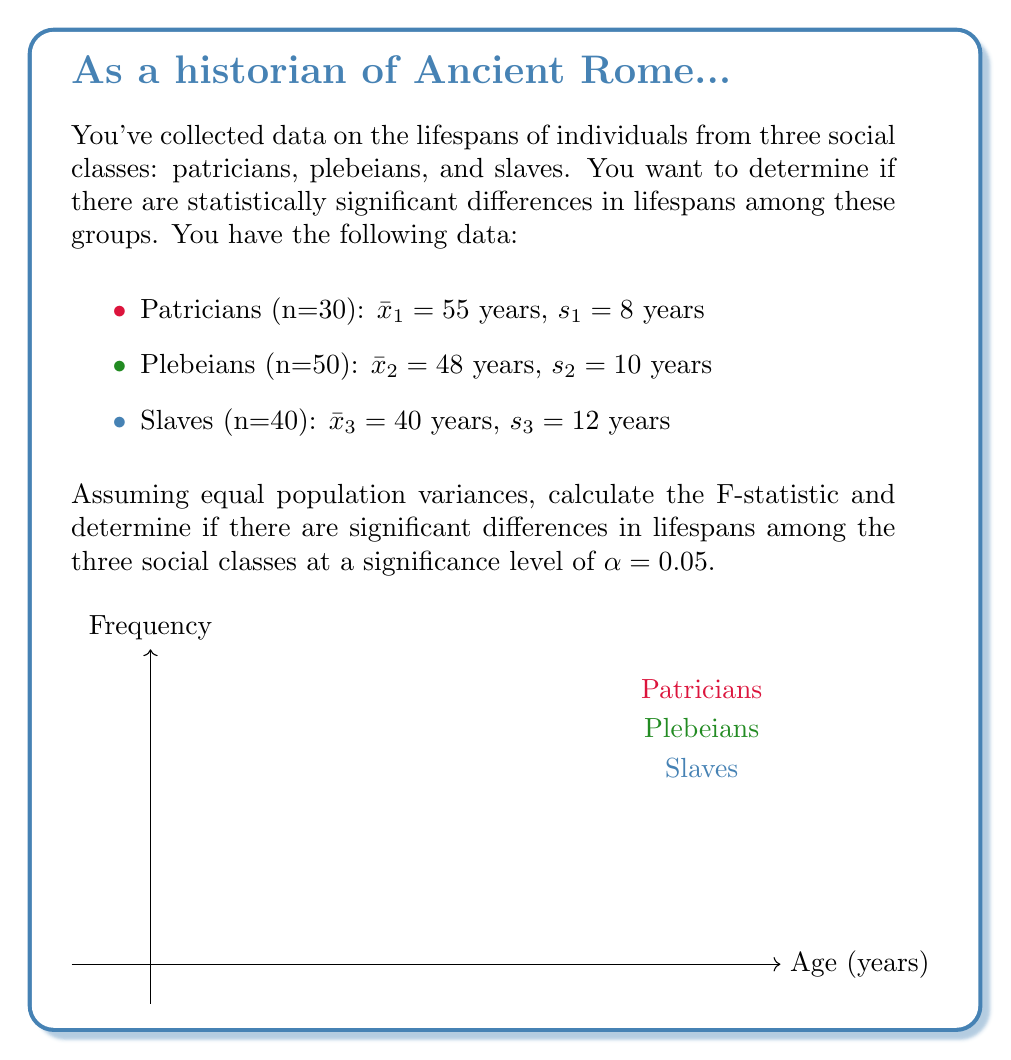Help me with this question. To determine if there are statistically significant differences in lifespans among the three social classes, we'll use one-way ANOVA (Analysis of Variance). The steps are as follows:

1) First, calculate the overall mean:
   $$\bar{x} = \frac{n_1\bar{x}_1 + n_2\bar{x}_2 + n_3\bar{x}_3}{n_1 + n_2 + n_3} = \frac{30(55) + 50(48) + 40(40)}{30 + 50 + 40} = 47.25$$

2) Calculate the between-group sum of squares (SSB):
   $$SSB = n_1(\bar{x}_1 - \bar{x})^2 + n_2(\bar{x}_2 - \bar{x})^2 + n_3(\bar{x}_3 - \bar{x})^2$$
   $$SSB = 30(55 - 47.25)^2 + 50(48 - 47.25)^2 + 40(40 - 47.25)^2 = 4281.25$$

3) Calculate the within-group sum of squares (SSW):
   $$SSW = (n_1 - 1)s_1^2 + (n_2 - 1)s_2^2 + (n_3 - 1)s_3^2$$
   $$SSW = 29(8^2) + 49(10^2) + 39(12^2) = 11696$$

4) Calculate the degrees of freedom:
   Between-group: $df_B = k - 1 = 3 - 1 = 2$ (where k is the number of groups)
   Within-group: $df_W = N - k = (30 + 50 + 40) - 3 = 117$ (where N is the total sample size)

5) Calculate the mean squares:
   $$MSB = \frac{SSB}{df_B} = \frac{4281.25}{2} = 2140.625$$
   $$MSW = \frac{SSW}{df_W} = \frac{11696}{117} = 99.966$$

6) Calculate the F-statistic:
   $$F = \frac{MSB}{MSW} = \frac{2140.625}{99.966} = 21.414$$

7) Find the critical F-value:
   For α = 0.05, $df_B = 2$, and $df_W = 117$, the critical F-value is approximately 3.07.

8) Compare the calculated F-statistic to the critical F-value:
   Since 21.414 > 3.07, we reject the null hypothesis.

Therefore, there are statistically significant differences in lifespans among the three social classes at the 0.05 significance level.
Answer: F(2, 117) = 21.414, p < 0.05 